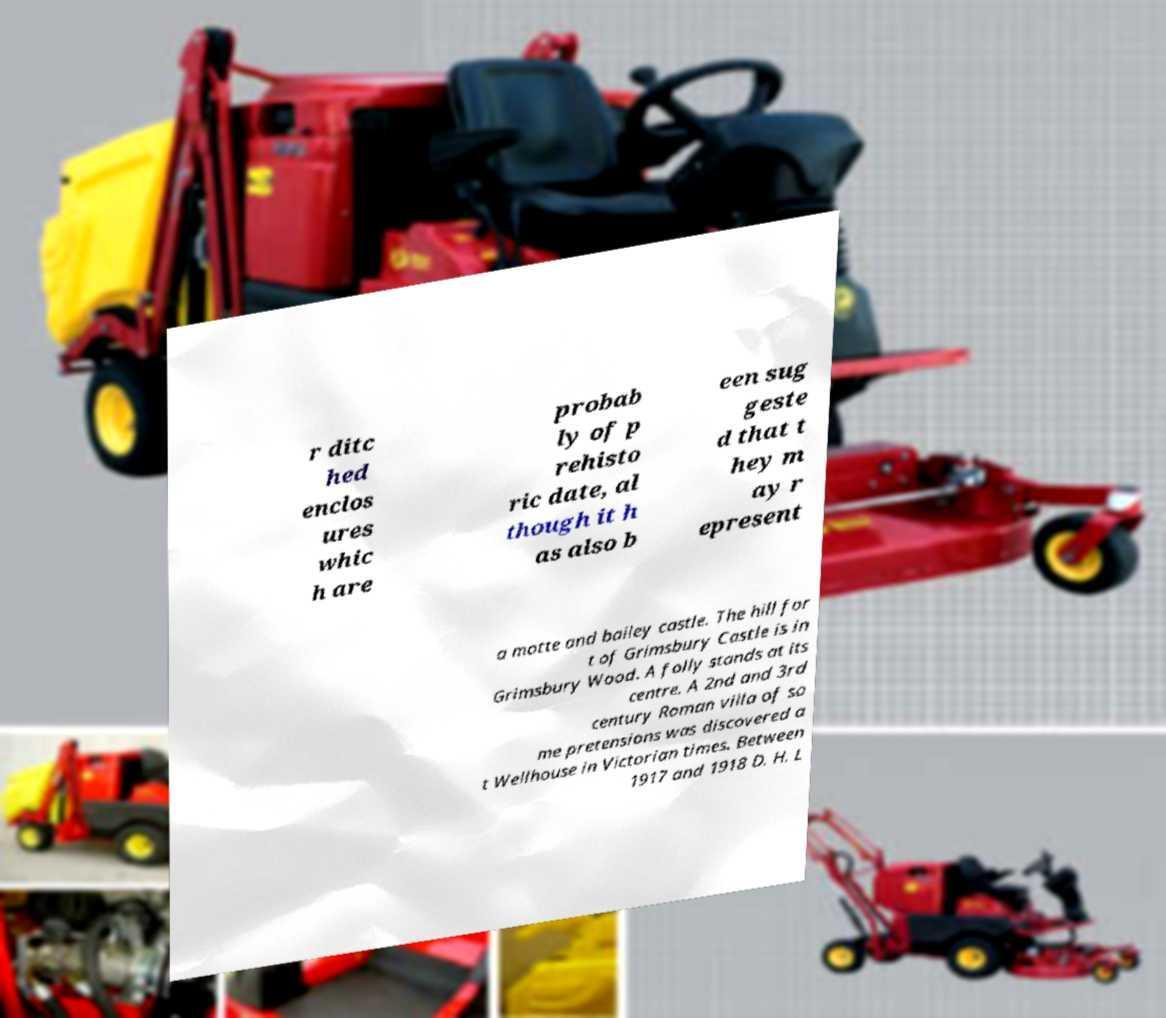Can you accurately transcribe the text from the provided image for me? r ditc hed enclos ures whic h are probab ly of p rehisto ric date, al though it h as also b een sug geste d that t hey m ay r epresent a motte and bailey castle. The hill for t of Grimsbury Castle is in Grimsbury Wood. A folly stands at its centre. A 2nd and 3rd century Roman villa of so me pretensions was discovered a t Wellhouse in Victorian times. Between 1917 and 1918 D. H. L 